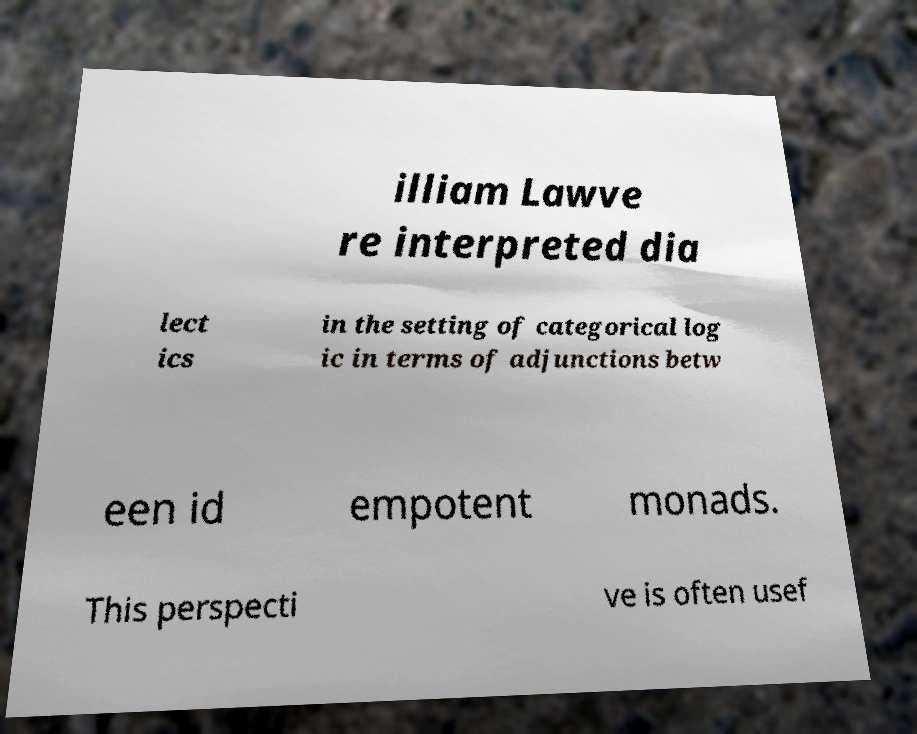Could you assist in decoding the text presented in this image and type it out clearly? illiam Lawve re interpreted dia lect ics in the setting of categorical log ic in terms of adjunctions betw een id empotent monads. This perspecti ve is often usef 